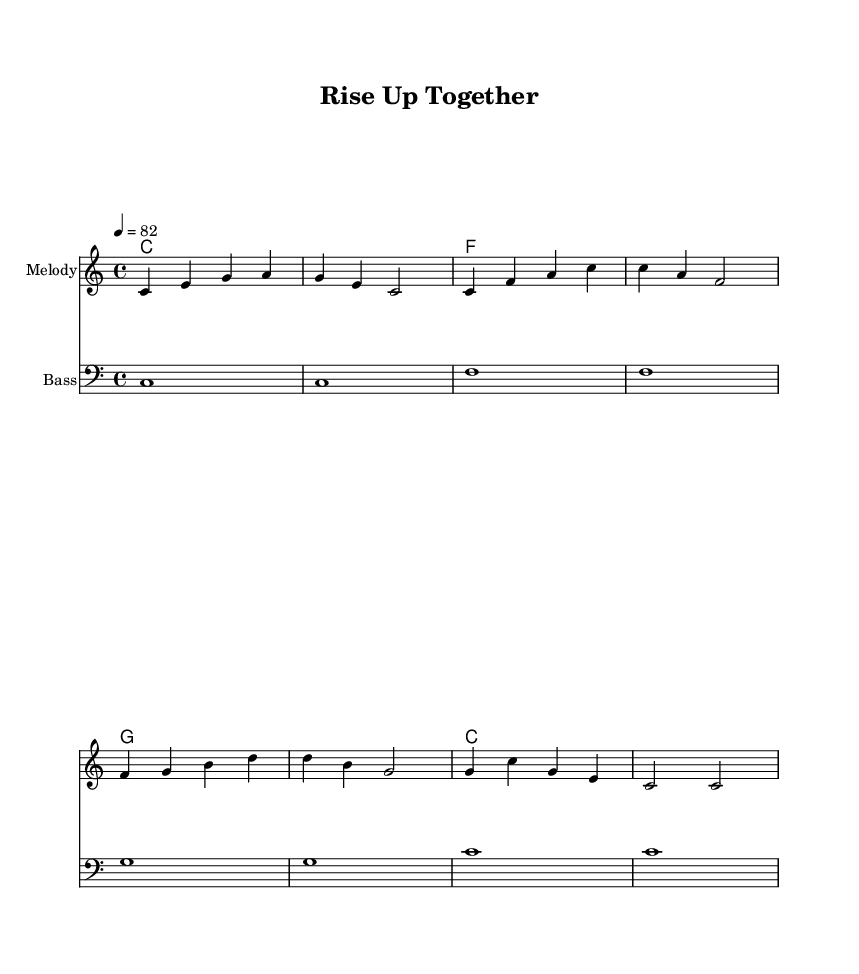What is the time signature of this music? The time signature is indicated at the beginning of the score as 4/4, meaning there are four beats in each measure and the quarter note receives one beat.
Answer: 4/4 What is the key signature of this music? The key signature at the beginning shows no sharps or flats, which is characteristic of C major.
Answer: C major What is the tempo of this piece? The tempo marking states "4 = 82," indicating that there should be 82 beats per minute, with each beat represented by a quarter note.
Answer: 82 How many measures are in the melody? By counting the measures in the provided melody section, there are a total of eight measures that are clearly delineated by the bar lines.
Answer: 8 What is the first lyric of the verse? The verse begins with the lyric "Rise up to," which can be found as the first set of words aligned under the melody in the lyric section.
Answer: Rise up to Identify the instrument used for the bass part. The bass part is labeled at the beginning of the score with the 'Bass' instrument name, indicating that a bass clef is used for this section.
Answer: Bass Which chord is played in the third measure of the score? The chord played in the third measure is identified as 'f' under the harmonies section, marking the specific chord for that moment in the music.
Answer: f 